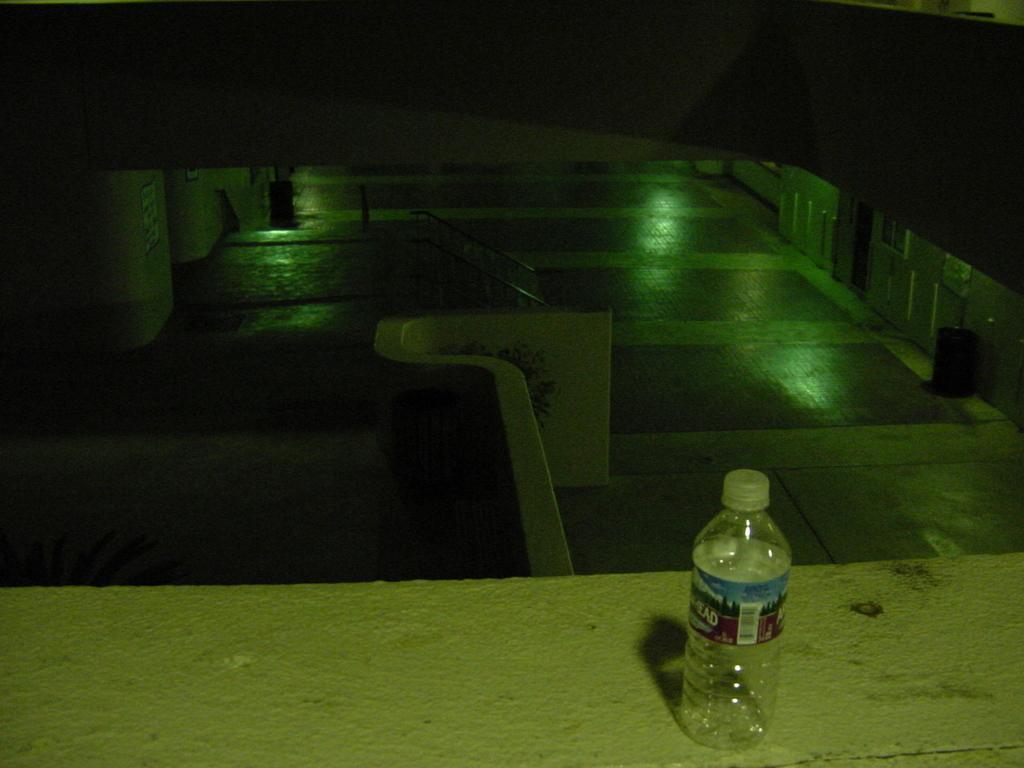Please provide a concise description of this image. An empty water bottle is placed on barrier wall. 